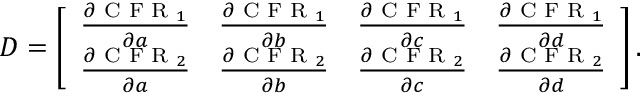Convert formula to latex. <formula><loc_0><loc_0><loc_500><loc_500>\begin{array} { r } { D = \left [ \begin{array} { l l l l } { \frac { \partial C F R _ { 1 } } { \partial a } } & { \frac { \partial C F R _ { 1 } } { \partial b } } & { \frac { \partial C F R _ { 1 } } { \partial c } } & { \frac { \partial C F R _ { 1 } } { \partial d } } \\ { \frac { \partial C F R _ { 2 } } { \partial a } } & { \frac { \partial C F R _ { 2 } } { \partial b } } & { \frac { \partial C F R _ { 2 } } { \partial c } } & { \frac { \partial C F R _ { 2 } } { \partial d } } \end{array} \right ] . } \end{array}</formula> 